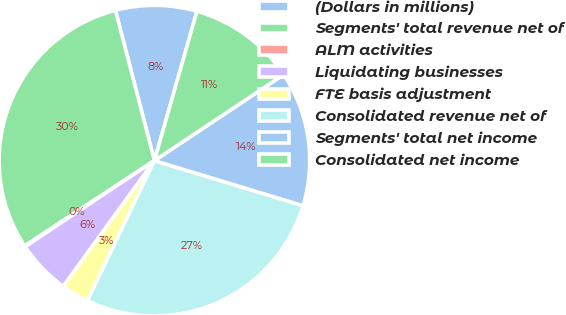<chart> <loc_0><loc_0><loc_500><loc_500><pie_chart><fcel>(Dollars in millions)<fcel>Segments' total revenue net of<fcel>ALM activities<fcel>Liquidating businesses<fcel>FTE basis adjustment<fcel>Consolidated revenue net of<fcel>Segments' total net income<fcel>Consolidated net income<nl><fcel>8.46%<fcel>30.21%<fcel>0.1%<fcel>5.67%<fcel>2.88%<fcel>27.42%<fcel>14.03%<fcel>11.24%<nl></chart> 